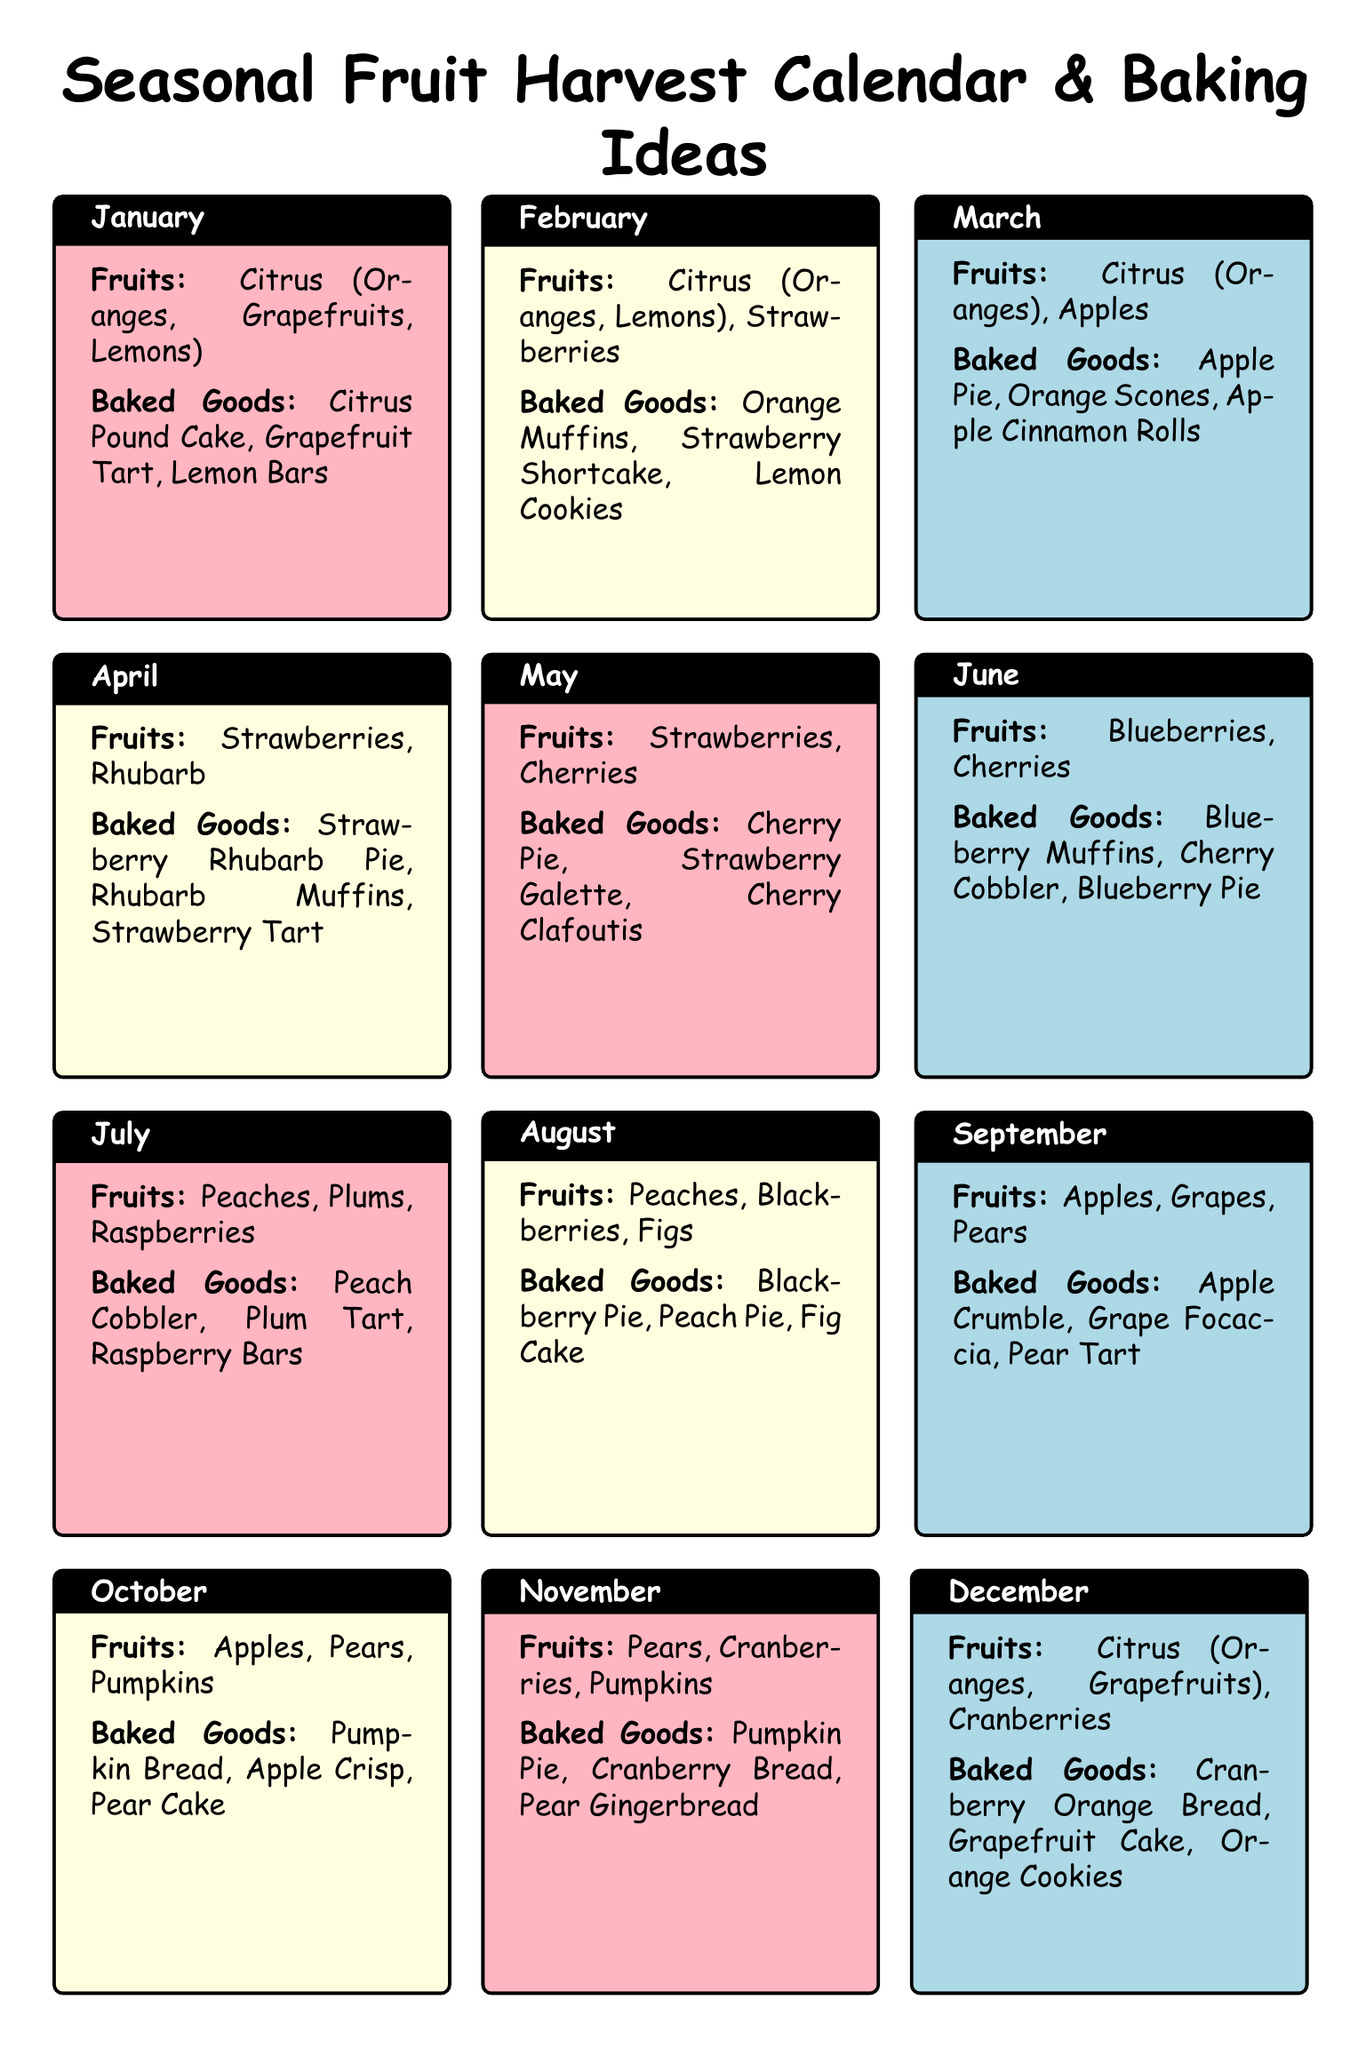What fruits are in season in January? The fruits listed for January in the document are Citrus (Oranges, Grapefruits, Lemons).
Answer: Citrus (Oranges, Grapefruits, Lemons) Which baked good is recommended for April? The document suggests three baked goods for April, including Strawberry Rhubarb Pie.
Answer: Strawberry Rhubarb Pie How many different fruits are mentioned for August? The document lists three different fruits for August: Peaches, Blackberries, Figs.
Answer: 3 What is the recommended baked good with cranberries in November? The document mentions Cranberry Bread as a baked good for November.
Answer: Cranberry Bread Which month features Blueberries and Cherry Cobbler? The document specifies June for Blueberries and Cherry Cobbler.
Answer: June What is the common ingredient in both January and February baked goods? The document reveals that Citrus is a common ingredient in both months' baked goods.
Answer: Citrus Which month has the least variety of fruits listed? The document shows that June has the least variety with only two distinct fruits listed.
Answer: June What type of pie is suggested for September? The document suggests Apple Crumble as a baked good for September.
Answer: Apple Crumble 